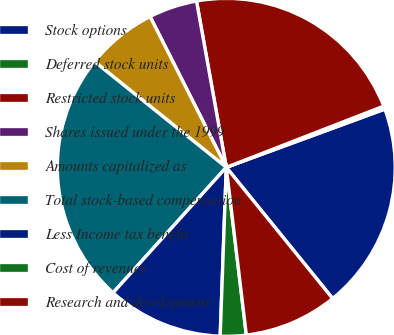<chart> <loc_0><loc_0><loc_500><loc_500><pie_chart><fcel>Stock options<fcel>Deferred stock units<fcel>Restricted stock units<fcel>Shares issued under the 1999<fcel>Amounts capitalized as<fcel>Total stock-based compensation<fcel>Less Income tax benefit<fcel>Cost of revenues<fcel>Research and development<nl><fcel>19.76%<fcel>0.3%<fcel>21.92%<fcel>4.63%<fcel>6.79%<fcel>24.08%<fcel>11.11%<fcel>2.47%<fcel>8.95%<nl></chart> 